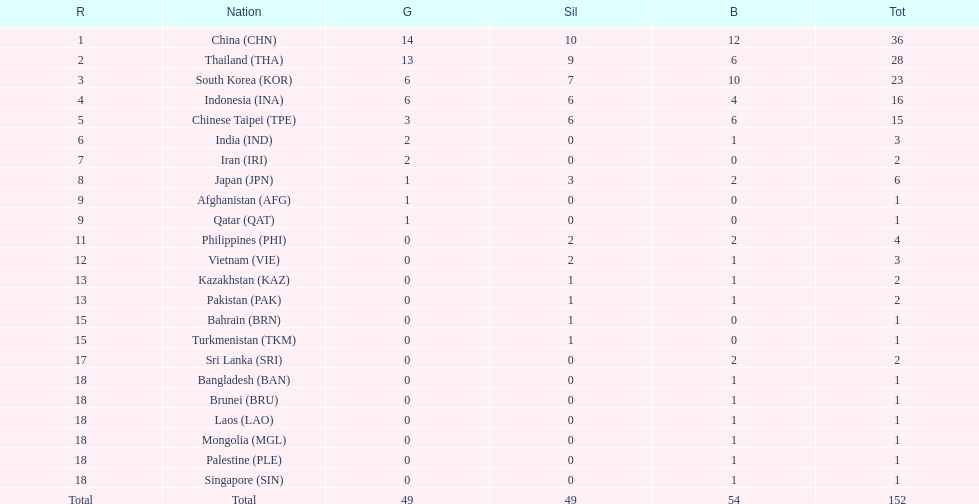How many total gold medal have been given? 49. 